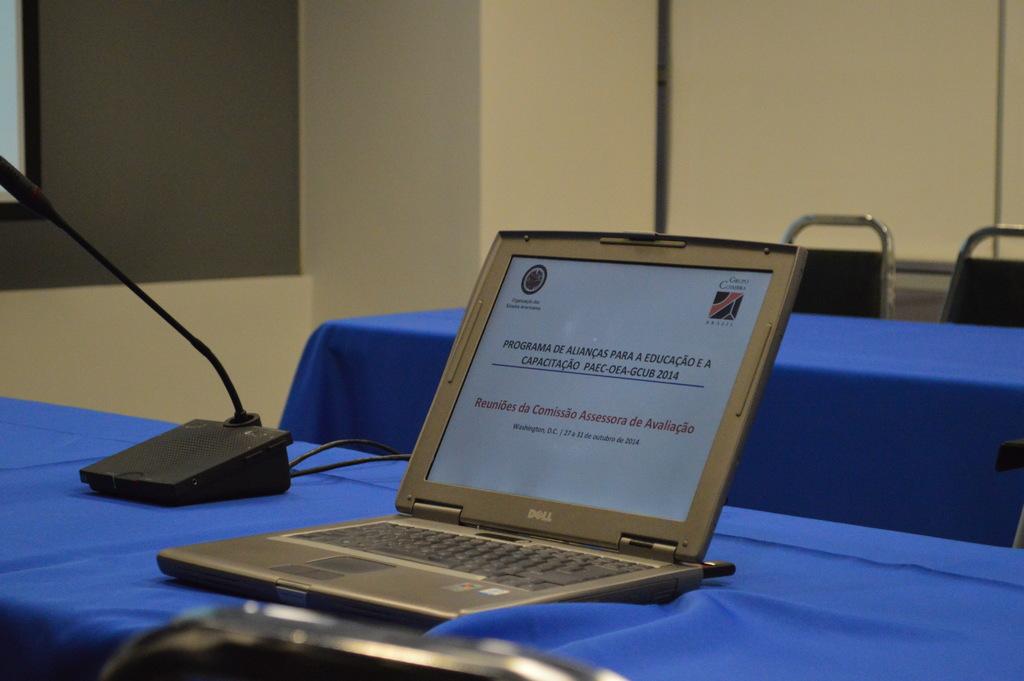What year is listed on the very last part of the sentence on the laptop screen?
Make the answer very short. 2014. 